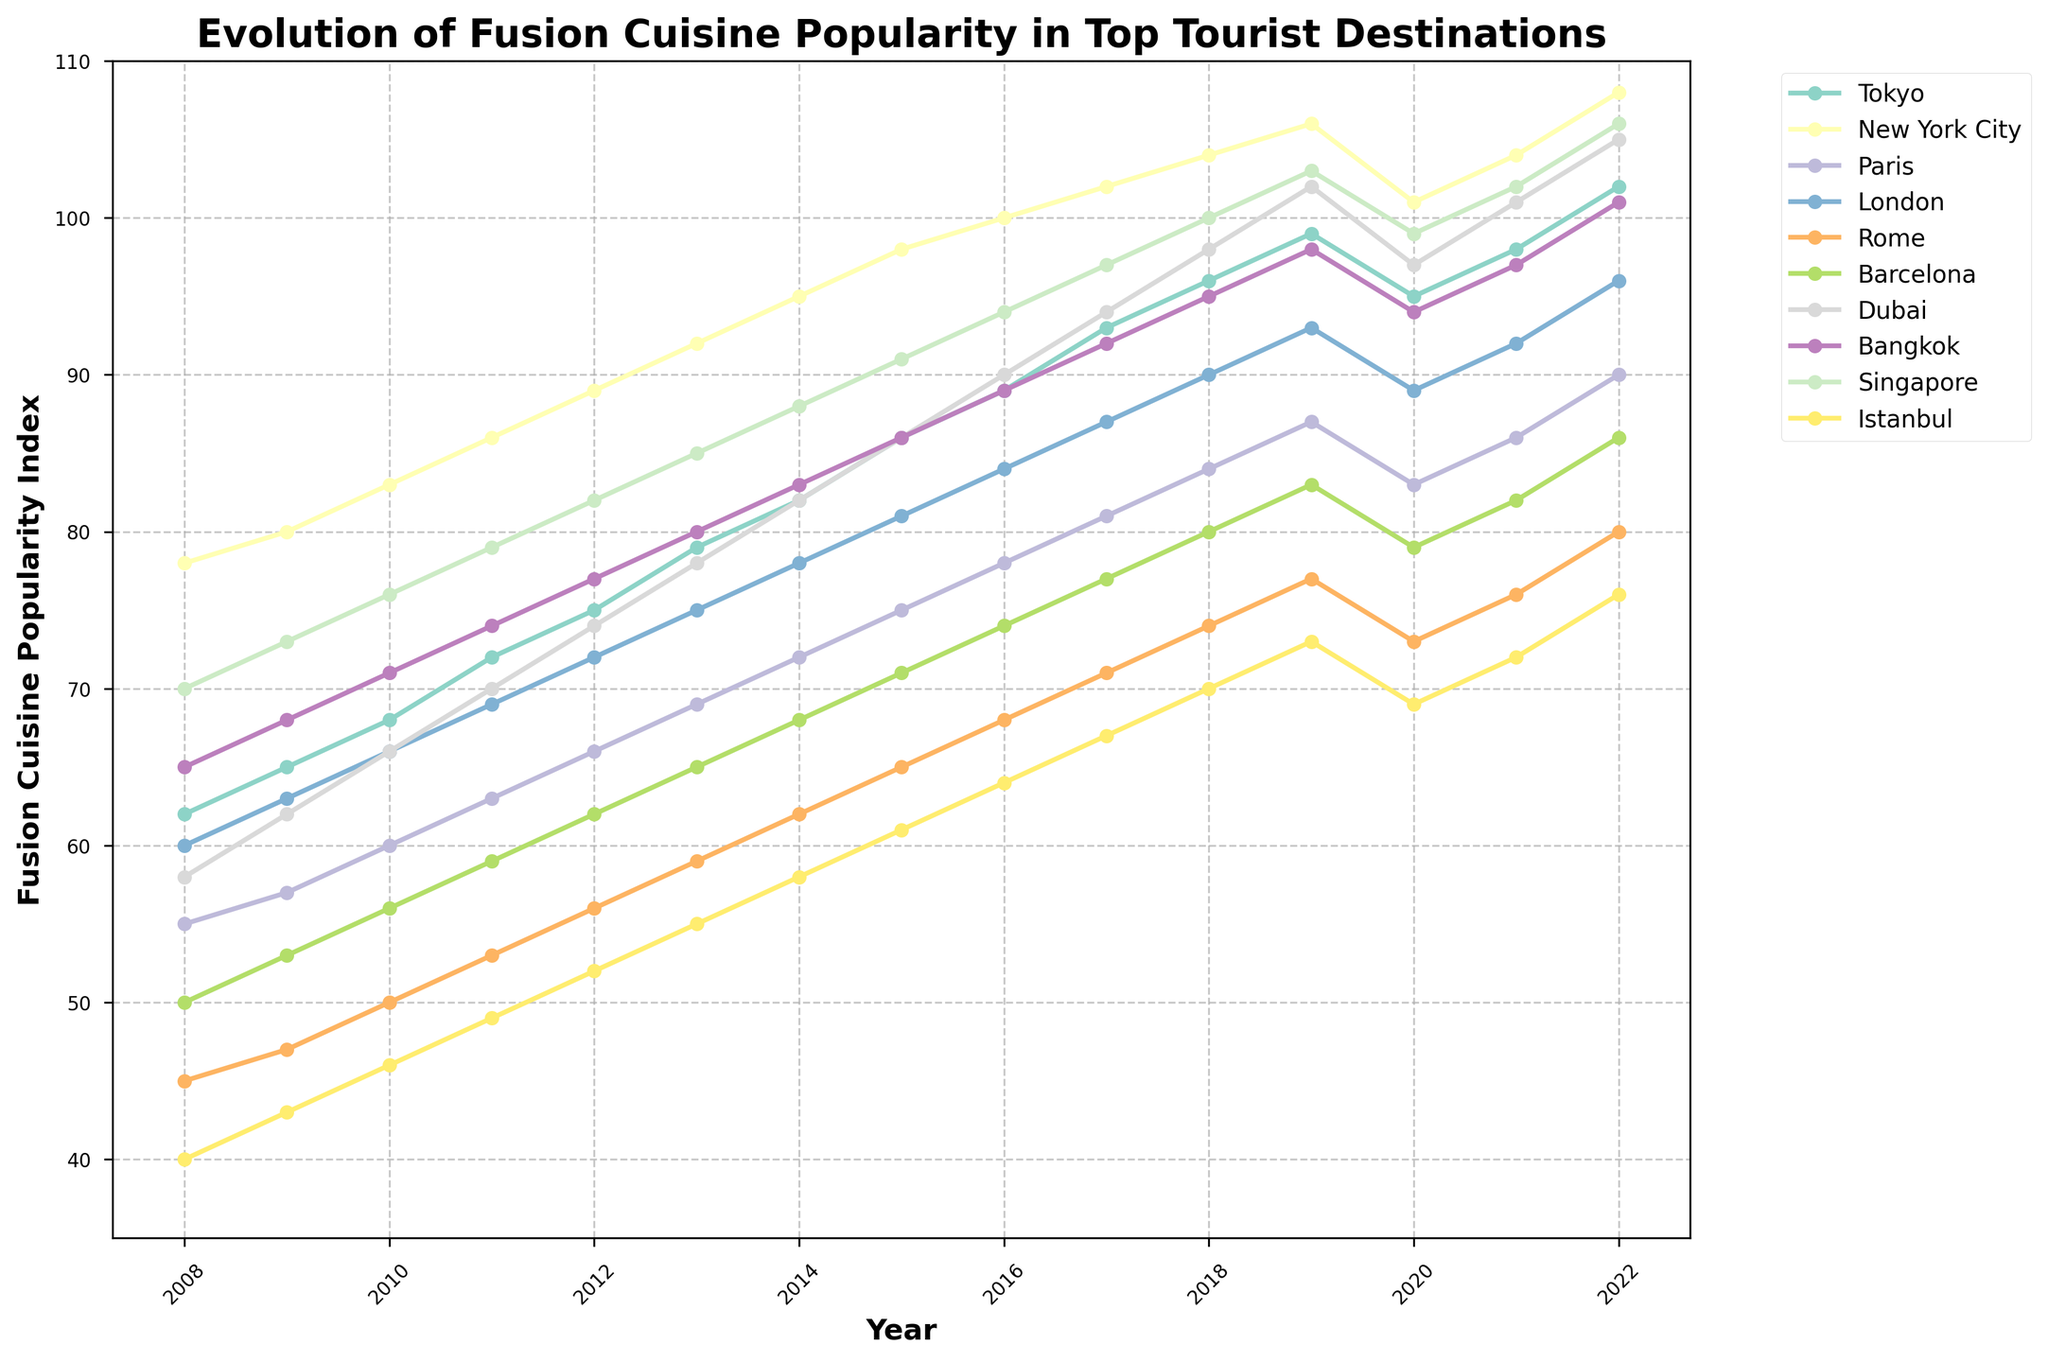Which city had the highest fusion cuisine popularity index in 2022? The figure shows the popularity index for each city in 2022. The city with the highest value in 2022 is Singapore.
Answer: Singapore How did the popularity index for New York City change from 2010 to 2020? According to the figure, the popularity index for New York City in 2010 was 83, and in 2020, it was 101. The change is 101 - 83 = 18.
Answer: Increased by 18 Which city saw the most significant increase in popularity index from 2008 to 2022? By looking at the starting (2008) and ending (2022) popularity indices for each city and calculating the difference, the city with the most significant increase is New York City, which went from 78 to 108, an increase of 30 points.
Answer: New York City Did any city experience a decline in their popularity index between 2019 and 2020? Observing the values from 2019 to 2020, Tokyo is the city that experienced a decline in its popularity index from 99 to 95.
Answer: Tokyo What is the average popularity index for Paris across the entire period? Adding the values for Paris over the 15 years (55 + 57 + 60 + 63 + 66 + 69 + 72 + 75 + 78 + 81 + 84 + 87 + 83 + 86 + 90 = 1186) and dividing by the number of years (15), gives an average of 1186/15 = 79.07.
Answer: 79.07 Which cities had a popularity index greater than or equal to 100 in any year? From the figure, New York City reaches and surpasses 100 in 2016, and Singapore reaches 100 in 2018, with both maintaining that level in subsequent years. Dubai also hits 100 in 2017 and maintains that level intermittently. The cities are New York City, Singapore, and Dubai.
Answer: New York City, Singapore, Dubai Between 2015 and 2018, which city had the most stable (smallest change) popularity index? By inspecting the changes in popularity indices between 2015 and 2018 for each city, Istanbul had the most stable index, changing only by 9 points (61 to 70).
Answer: Istanbul What is the trend in popularity index for Bangkok from 2008 to 2022? Observing the line representing Bangkok, the popularity index consistently increased every year except in 2020, where it slightly declined. Thus, the general trend is upward.
Answer: Upward trend 